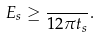<formula> <loc_0><loc_0><loc_500><loc_500>E _ { s } \geq \frac { } { 1 2 \pi t _ { s } } .</formula> 